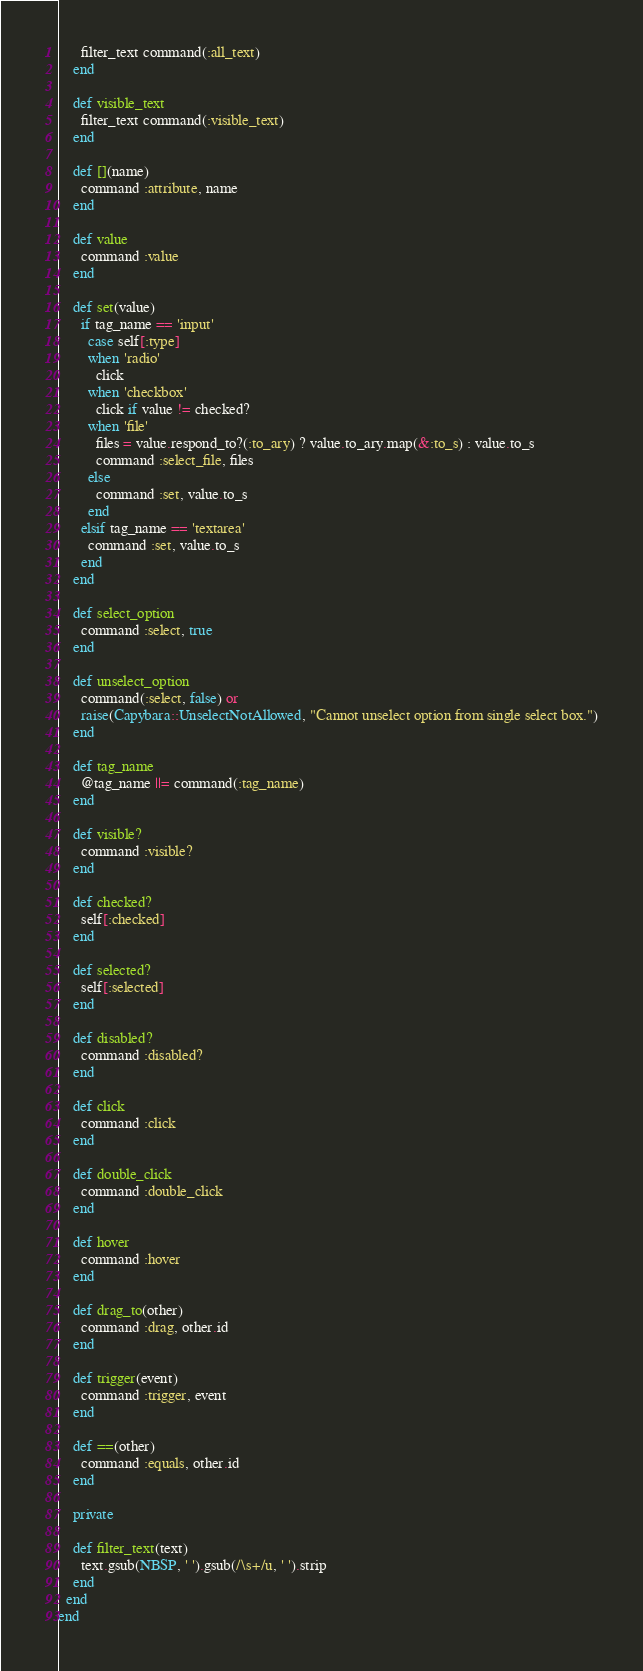Convert code to text. <code><loc_0><loc_0><loc_500><loc_500><_Ruby_>      filter_text command(:all_text)
    end

    def visible_text
      filter_text command(:visible_text)
    end

    def [](name)
      command :attribute, name
    end

    def value
      command :value
    end

    def set(value)
      if tag_name == 'input'
        case self[:type]
        when 'radio'
          click
        when 'checkbox'
          click if value != checked?
        when 'file'
          files = value.respond_to?(:to_ary) ? value.to_ary.map(&:to_s) : value.to_s
          command :select_file, files
        else
          command :set, value.to_s
        end
      elsif tag_name == 'textarea'
        command :set, value.to_s
      end
    end

    def select_option
      command :select, true
    end

    def unselect_option
      command(:select, false) or
      raise(Capybara::UnselectNotAllowed, "Cannot unselect option from single select box.")
    end

    def tag_name
      @tag_name ||= command(:tag_name)
    end

    def visible?
      command :visible?
    end

    def checked?
      self[:checked]
    end

    def selected?
      self[:selected]
    end

    def disabled?
      command :disabled?
    end

    def click
      command :click
    end

    def double_click
      command :double_click
    end

    def hover
      command :hover
    end

    def drag_to(other)
      command :drag, other.id
    end

    def trigger(event)
      command :trigger, event
    end

    def ==(other)
      command :equals, other.id
    end

    private

    def filter_text(text)
      text.gsub(NBSP, ' ').gsub(/\s+/u, ' ').strip
    end
  end
end
</code> 